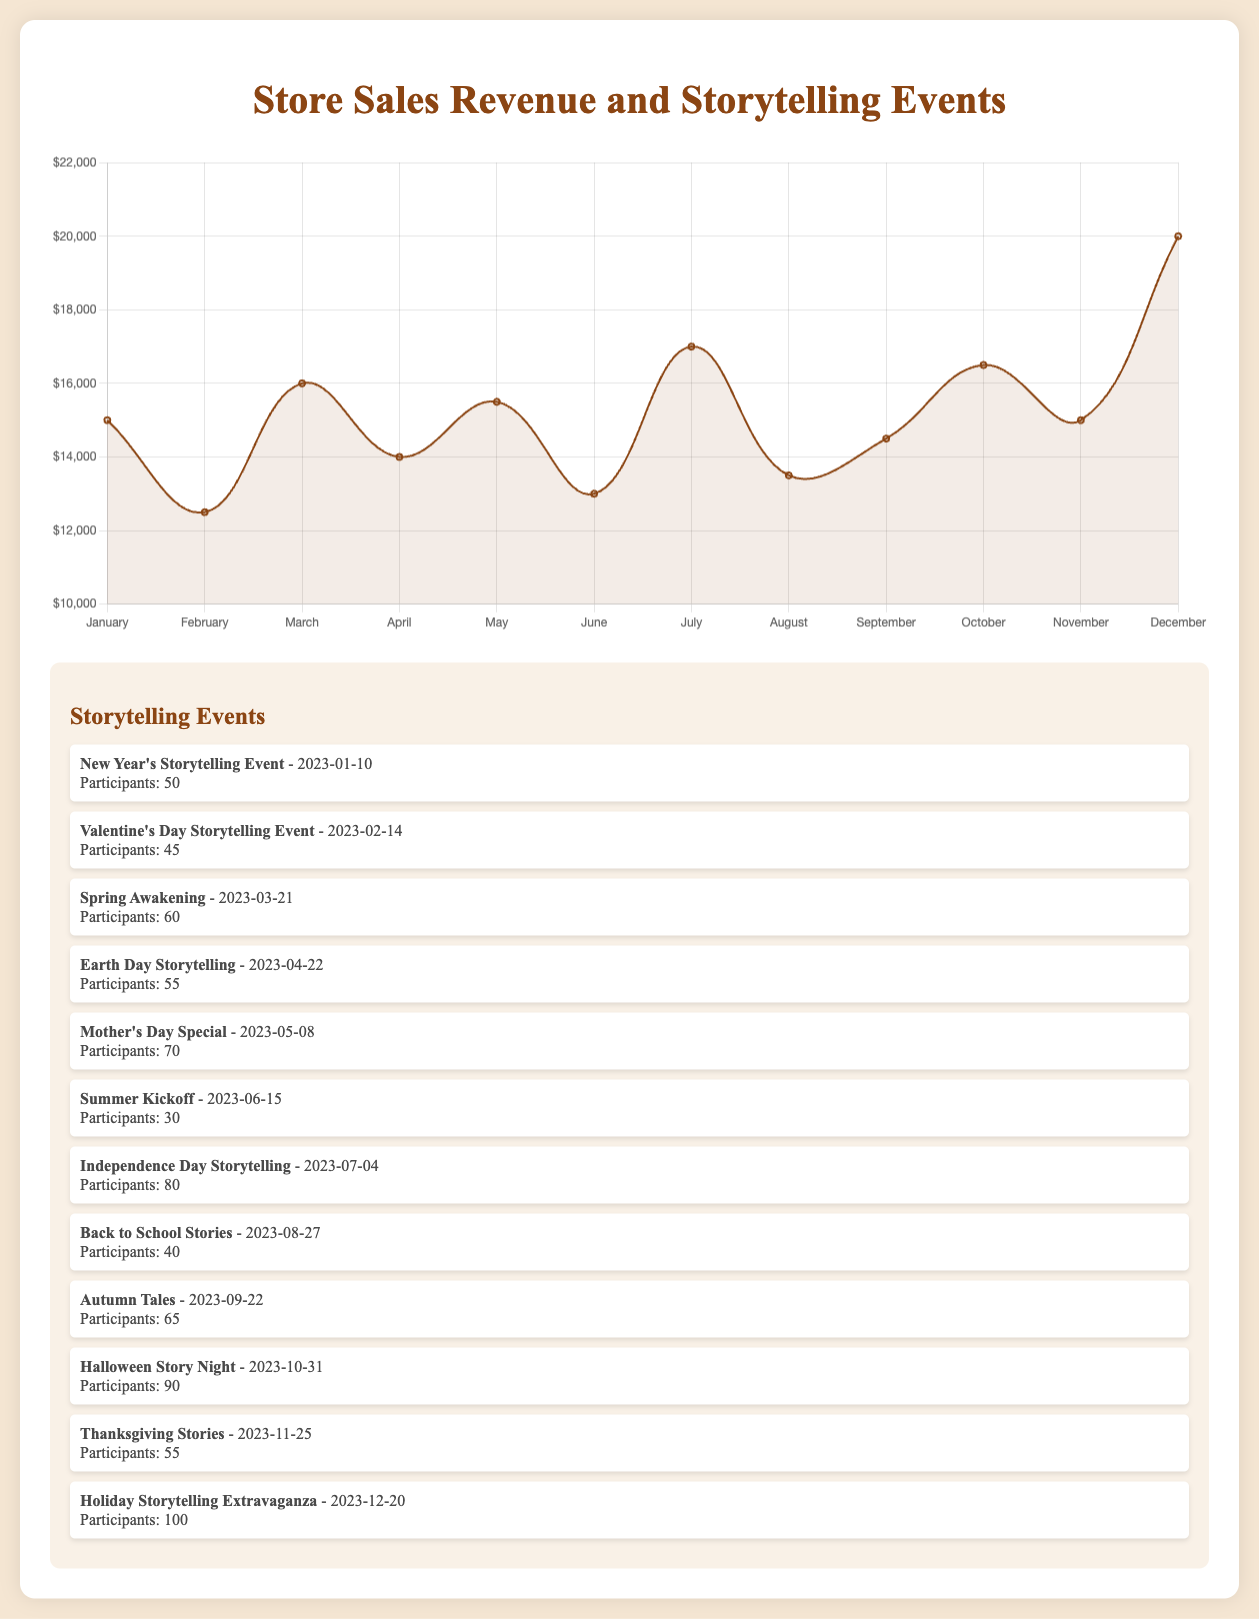Which month had the highest sales revenue? The tallest peak on the curve represents the month with the highest sales revenue, which is December with $20,000.
Answer: December Which month had the lowest sales revenue? The lowest point on the curve indicates the month with the lowest sales revenue, which is February with $12,500.
Answer: February How does the sales revenue in July compare to the sales revenue in May? The sales revenue in July ($17,000) is greater than the sales revenue in May ($15,500).
Answer: July has higher revenue than May What is the total revenue for the first half of the year? Add the sales revenues from January to June: $15,000 (January) + $12,500 (February) + $16,000 (March) + $14,000 (April) + $15,500 (May) + $13,000 (June) = $86,000.
Answer: $86,000 What is the average monthly revenue over the entire year? Add all the monthly revenues and divide by 12: ($15,000 + $12,500 + $16,000 + $14,000 + $15,500 + $13,000 + $17,000 + $13,500 + $14,500 + $16,500 + $15,000 + $20,000) / 12 = $172,500 / 12 = $14,375.
Answer: $14,375 In which month did the store hold a Valentine's Day Storytelling Event, and how did the revenue perform in that month compared to the previous month? The Valentine's Day Storytelling Event was in February. Compare February's revenue ($12,500) with January's revenue ($15,000); February's revenue is lower.
Answer: February's revenue was lower than January's Which month showed the most significant increase in sales revenue from the previous month? Identify the month-to-month differences and find the largest: June to July increase is $17,000 - $13,000 = $4,000, the highest jump.
Answer: June to July Which month showed the most significant decrease in sales revenue from the previous month? Identify the month-to-month differences and find the largest drop: March to April decrease is $16,000 - $14,000 = $2,000.
Answer: March to April What is the median sales revenue for the year? Order the monthly sales revenues and find the middle value(s): $12,500, $13,000, $13,500, $14,000, $14,500, $15,000, $15,000, $15,500, $16,000, $16,500, $17,000, $20,000. Median is the average of the 6th and 7th values: ($15,000 + $15,000) / 2 = $15,000.
Answer: $15,000 How did the sales revenue in October compare to the sales revenue in September and November? October's revenue is $16,500. Compare it to September ($14,500) and November ($15,000); October's revenue is higher than both.
Answer: Higher than both September and November 